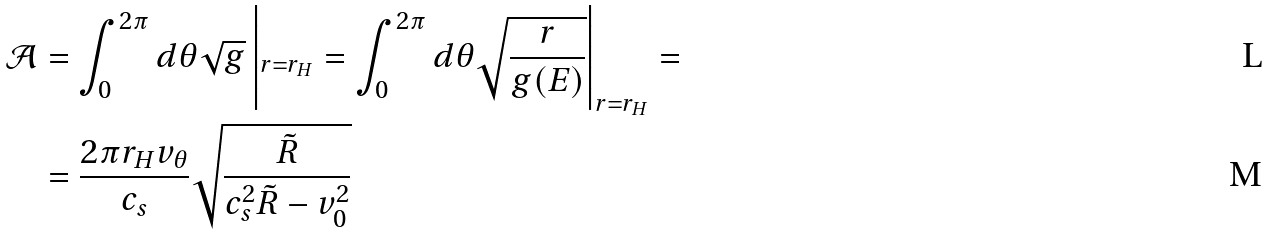<formula> <loc_0><loc_0><loc_500><loc_500>\mathcal { A } & = \int _ { 0 } ^ { 2 \pi } d \theta \sqrt { g } \left | _ { r = r _ { H } } = \int _ { 0 } ^ { 2 \pi } d \theta \sqrt { \frac { r } { g ( E ) } } \right | _ { r = r _ { H } } = \\ & = \frac { 2 \pi r _ { H } v _ { \theta } } { c _ { s } } \sqrt { \frac { \tilde { R } } { c _ { s } ^ { 2 } \tilde { R } - v _ { 0 } ^ { 2 } } }</formula> 